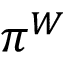Convert formula to latex. <formula><loc_0><loc_0><loc_500><loc_500>\pi ^ { W }</formula> 